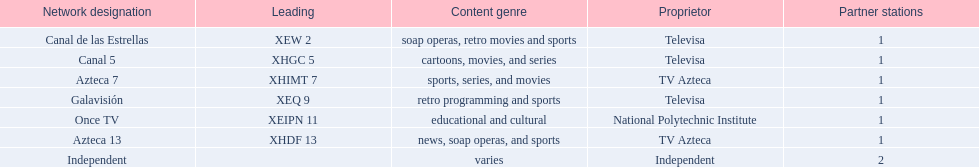What television stations are in morelos? Canal de las Estrellas, Canal 5, Azteca 7, Galavisión, Once TV, Azteca 13, Independent. Of those which network is owned by national polytechnic institute? Once TV. 